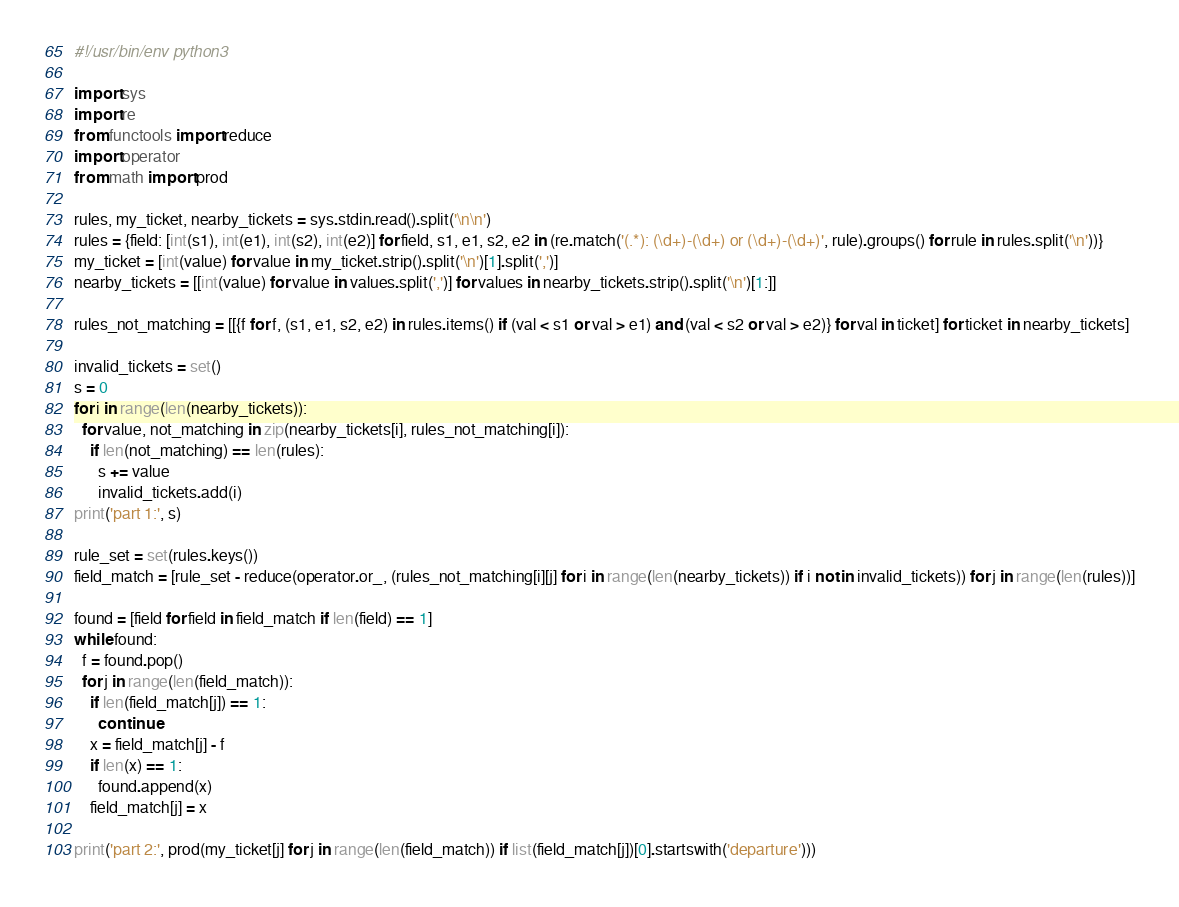<code> <loc_0><loc_0><loc_500><loc_500><_Python_>#!/usr/bin/env python3

import sys
import re
from functools import reduce
import operator
from math import prod

rules, my_ticket, nearby_tickets = sys.stdin.read().split('\n\n')
rules = {field: [int(s1), int(e1), int(s2), int(e2)] for field, s1, e1, s2, e2 in (re.match('(.*): (\d+)-(\d+) or (\d+)-(\d+)', rule).groups() for rule in rules.split('\n'))}
my_ticket = [int(value) for value in my_ticket.strip().split('\n')[1].split(',')]
nearby_tickets = [[int(value) for value in values.split(',')] for values in nearby_tickets.strip().split('\n')[1:]]

rules_not_matching = [[{f for f, (s1, e1, s2, e2) in rules.items() if (val < s1 or val > e1) and (val < s2 or val > e2)} for val in ticket] for ticket in nearby_tickets]

invalid_tickets = set()
s = 0
for i in range(len(nearby_tickets)):
  for value, not_matching in zip(nearby_tickets[i], rules_not_matching[i]):
    if len(not_matching) == len(rules):
      s += value
      invalid_tickets.add(i)
print('part 1:', s)

rule_set = set(rules.keys())
field_match = [rule_set - reduce(operator.or_, (rules_not_matching[i][j] for i in range(len(nearby_tickets)) if i not in invalid_tickets)) for j in range(len(rules))]

found = [field for field in field_match if len(field) == 1]
while found:
  f = found.pop()
  for j in range(len(field_match)):
    if len(field_match[j]) == 1:
      continue
    x = field_match[j] - f
    if len(x) == 1:
      found.append(x)
    field_match[j] = x

print('part 2:', prod(my_ticket[j] for j in range(len(field_match)) if list(field_match[j])[0].startswith('departure')))
</code> 